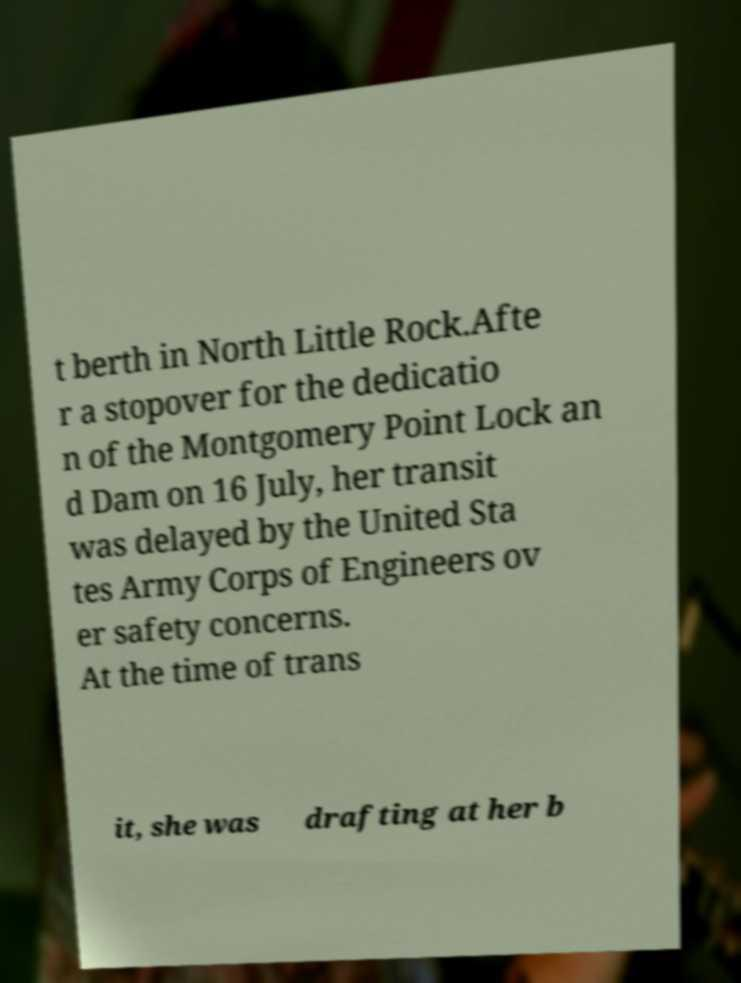Please read and relay the text visible in this image. What does it say? t berth in North Little Rock.Afte r a stopover for the dedicatio n of the Montgomery Point Lock an d Dam on 16 July, her transit was delayed by the United Sta tes Army Corps of Engineers ov er safety concerns. At the time of trans it, she was drafting at her b 